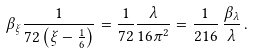Convert formula to latex. <formula><loc_0><loc_0><loc_500><loc_500>\beta _ { \xi } \frac { 1 } { 7 2 \left ( \xi - \frac { 1 } { 6 } \right ) } = \frac { 1 } { 7 2 } \frac { \lambda } { 1 6 \pi ^ { 2 } } = \frac { 1 } { 2 1 6 } \, \frac { \beta _ { \lambda } } { \lambda } \, .</formula> 